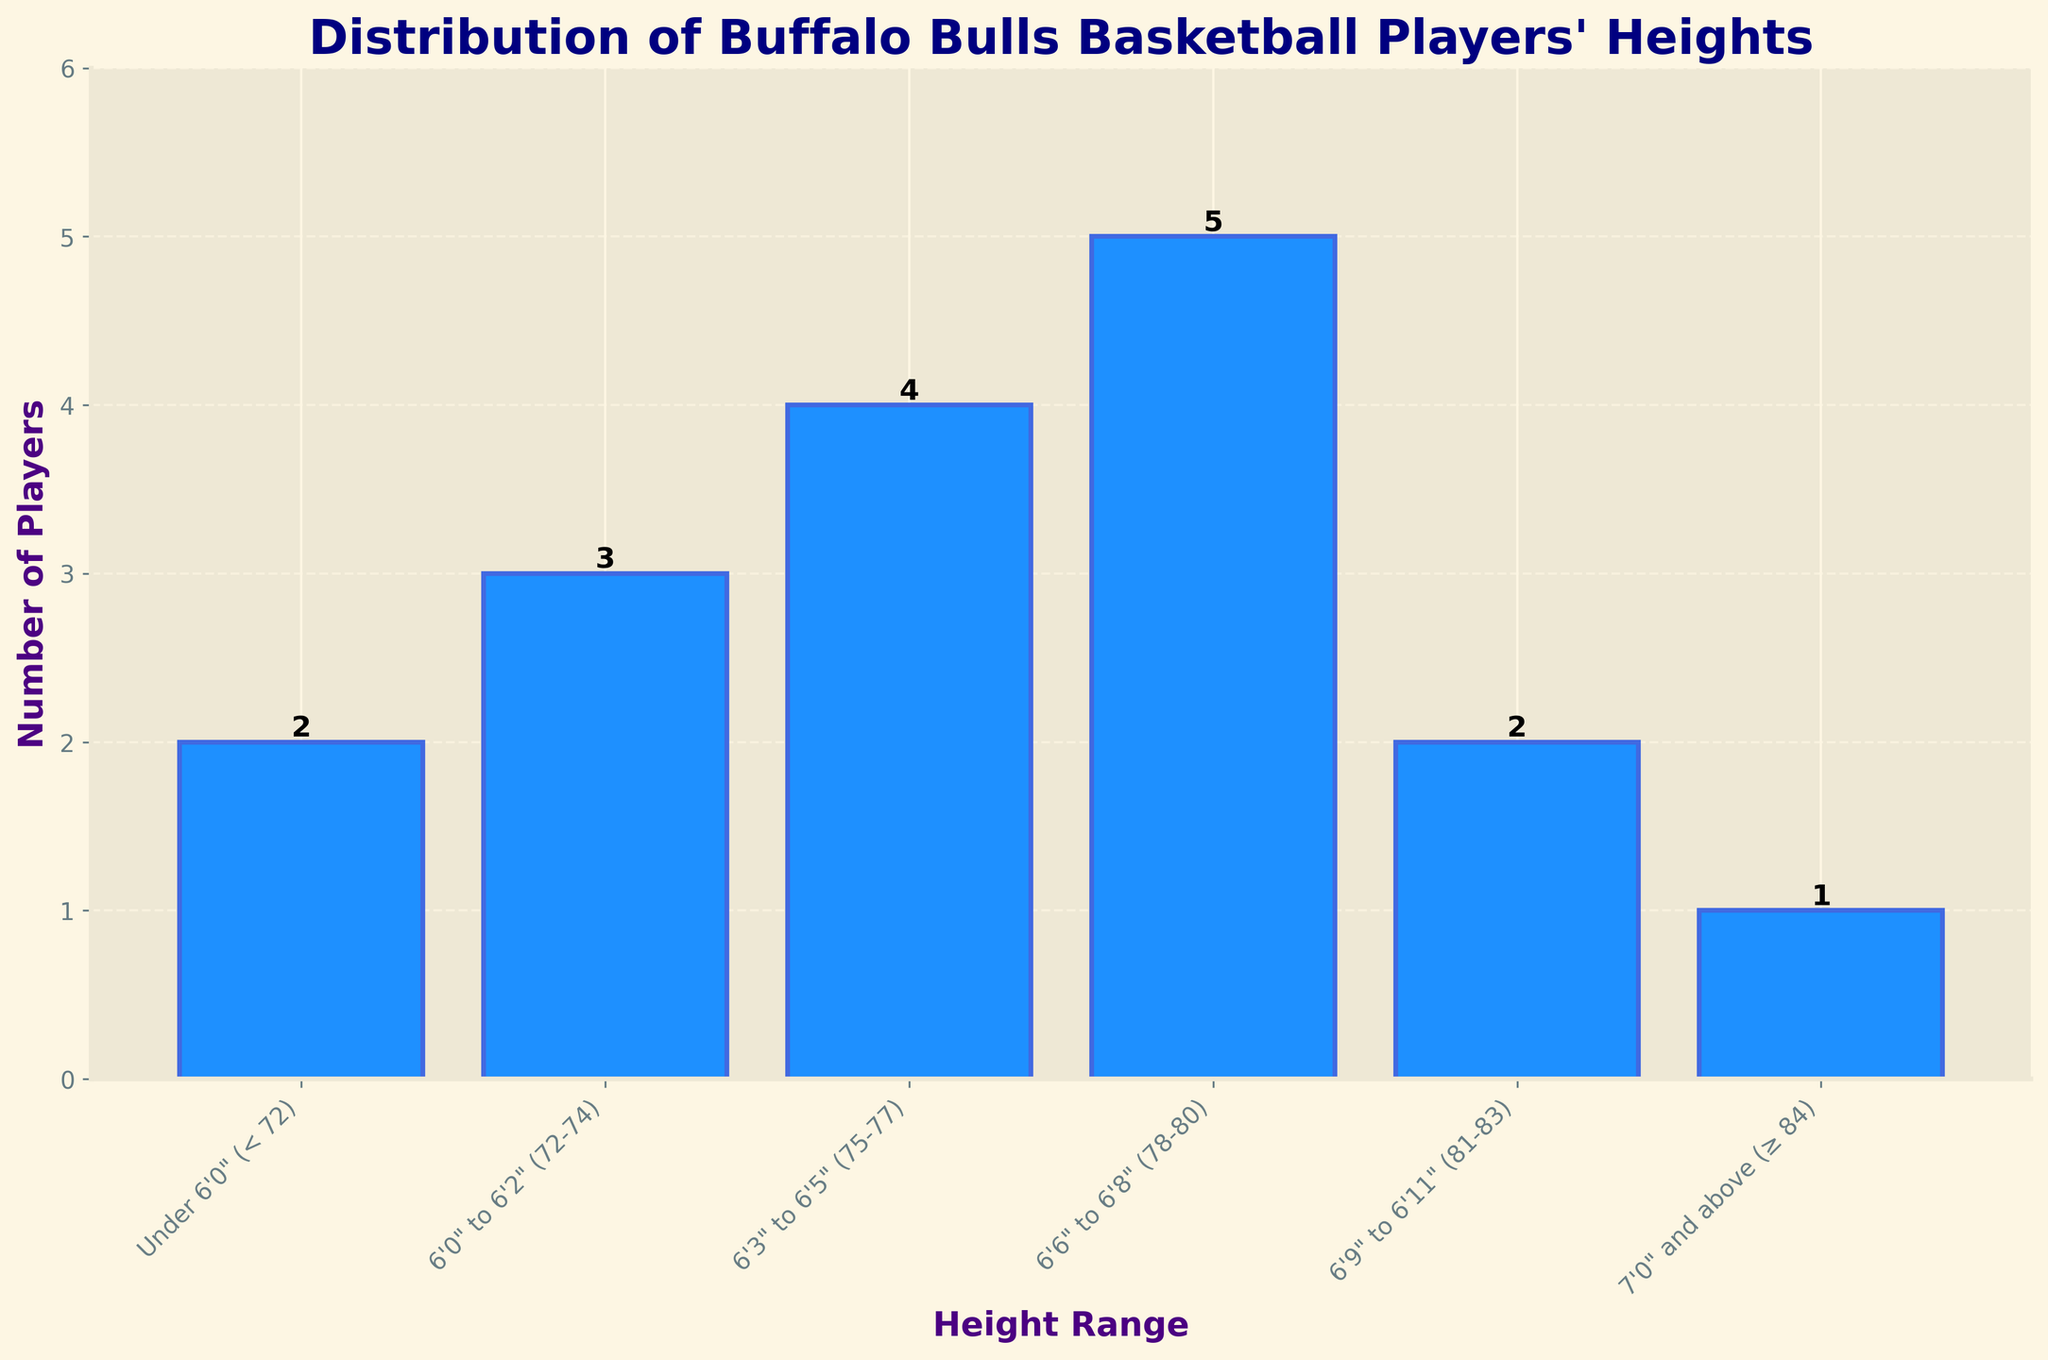What's the height range with the most Buffalo Bulls players? The height range with the tallest bar in the figure represents the range with the most players. From the figure, the 6'6" to 6'8" range has the tallest bar.
Answer: 6'6" to 6'8" How many players are shorter than 6'0"? Observe the bar for "Under 6'0" and note its height, which indicates the number of players. The figure shows 2 players in this range.
Answer: 2 What's the total number of players taller than 6'5"? Sum the number of players in the height ranges above 6'5". These ranges are 6'6" to 6'8" (5 players), 6'9" to 6'11" (2 players), and 7'0" and above (1 player). Adding these gives 5 + 2 + 1 = 8.
Answer: 8 Which height range has the fewest players and how many players are in it? Identify the shortest bar in the figure; it will represent the range with the fewest players. The bar for 7'0" and above is the shortest, showing 1 player.
Answer: 7'0" and above, 1 How many more players are there in the 6'6" to 6'8" range than in the 6'9" to 6'11" range? Subtract the number of players in the 6'9" to 6'11" range from those in the 6'6" to 6'8" range. There are 5 players in the 6'6" to 6'8" range and 2 in the 6'9" to 6'11" range. So, 5 - 2 = 3.
Answer: 3 What is the total number of players on the team? Add up the number of players across all height ranges. Total players = 2 (Under 6'0") + 3 (6'0" to 6'2") + 4 (6'3" to 6'5") + 5 (6'6" to 6'8") + 2 (6'9" to 6'11") + 1 (7'0" and above) = 17.
Answer: 17 Are there more players in the 6'3" to 6'5" range or the 6'0" to 6'2" range? Compare the heights of the bars for the 6'3" to 6'5" and the 6'0" to 6'2" ranges. The bar for 6'3" to 6'5" is taller, indicating more players.
Answer: 6'3" to 6'5" What percentage of players are between 6'3" and 6'8"? First, find the total number of players in the 6'3" to 6'5" (4) and 6'6" to 6'8" (5) ranges, which is 4 + 5 = 9. Then divide by the total number of players (17) and multiply by 100: (9/17) * 100 ≈ 52.94%.
Answer: 52.94% 